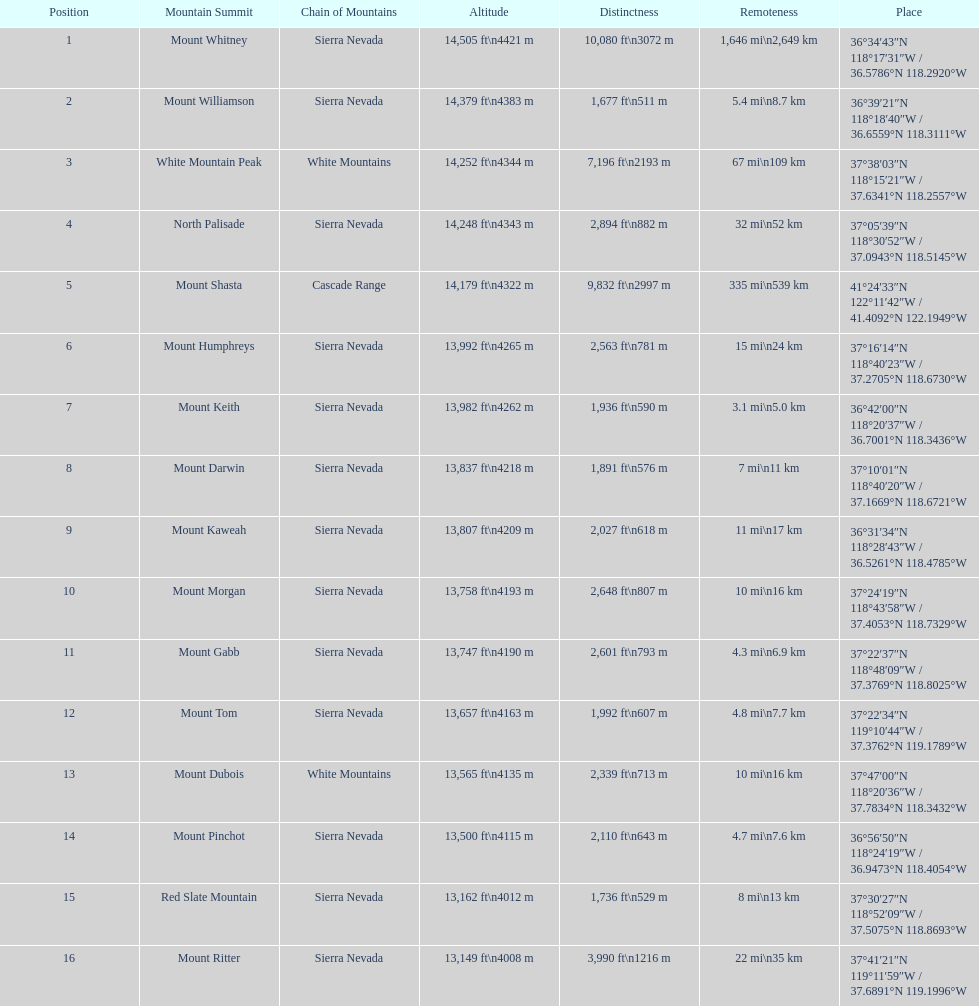Is the peak of mount keith above or below the peak of north palisade? Below. 